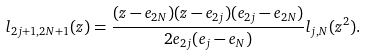Convert formula to latex. <formula><loc_0><loc_0><loc_500><loc_500>l _ { 2 j + 1 , 2 N + 1 } ( z ) = \frac { ( z - e _ { 2 N } ) ( z - e _ { 2 j } ) ( e _ { 2 j } - e _ { 2 N } ) } { 2 e _ { 2 j } ( e _ { j } - e _ { N } ) } l _ { j , N } ( z ^ { 2 } ) . \\</formula> 